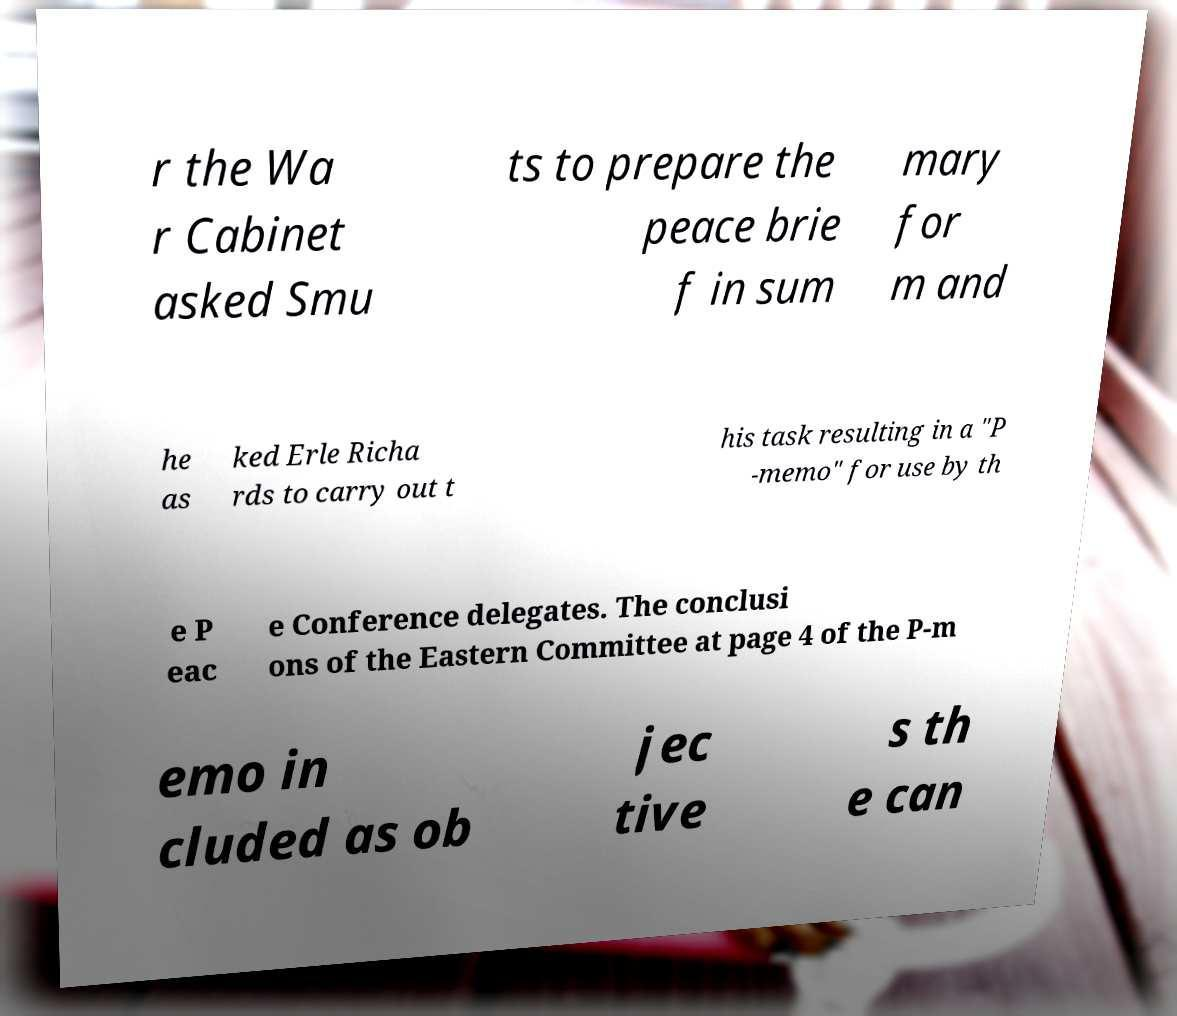Could you extract and type out the text from this image? r the Wa r Cabinet asked Smu ts to prepare the peace brie f in sum mary for m and he as ked Erle Richa rds to carry out t his task resulting in a "P -memo" for use by th e P eac e Conference delegates. The conclusi ons of the Eastern Committee at page 4 of the P-m emo in cluded as ob jec tive s th e can 